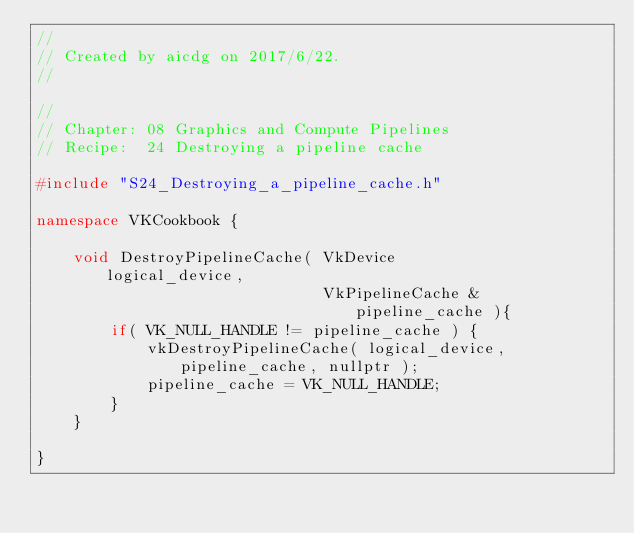<code> <loc_0><loc_0><loc_500><loc_500><_C++_>//
// Created by aicdg on 2017/6/22.
//

//
// Chapter: 08 Graphics and Compute Pipelines
// Recipe:  24 Destroying a pipeline cache

#include "S24_Destroying_a_pipeline_cache.h"

namespace VKCookbook {

    void DestroyPipelineCache( VkDevice          logical_device,
                               VkPipelineCache & pipeline_cache ){
        if( VK_NULL_HANDLE != pipeline_cache ) {
            vkDestroyPipelineCache( logical_device, pipeline_cache, nullptr );
            pipeline_cache = VK_NULL_HANDLE;
        }
    }

}</code> 